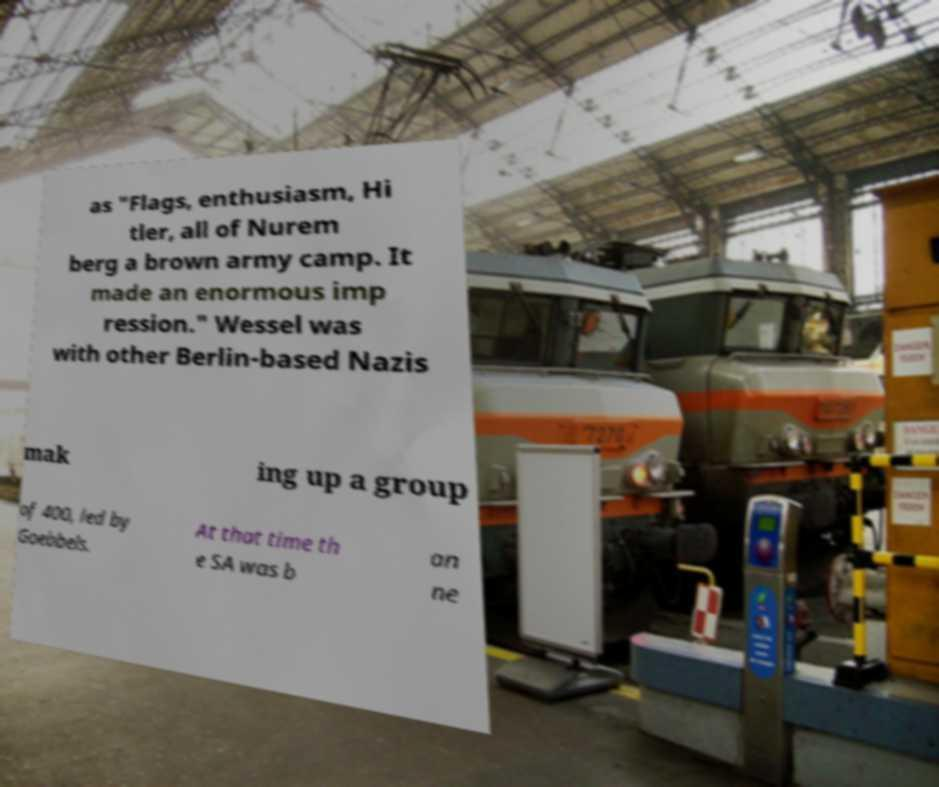Can you read and provide the text displayed in the image?This photo seems to have some interesting text. Can you extract and type it out for me? as "Flags, enthusiasm, Hi tler, all of Nurem berg a brown army camp. It made an enormous imp ression." Wessel was with other Berlin-based Nazis mak ing up a group of 400, led by Goebbels. At that time th e SA was b an ne 